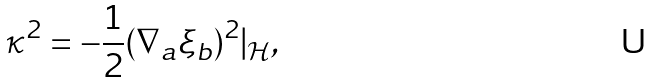<formula> <loc_0><loc_0><loc_500><loc_500>\kappa ^ { 2 } = - \frac { 1 } { 2 } ( \nabla _ { a } \xi _ { b } ) ^ { 2 } | _ { \mathcal { H } } ,</formula> 